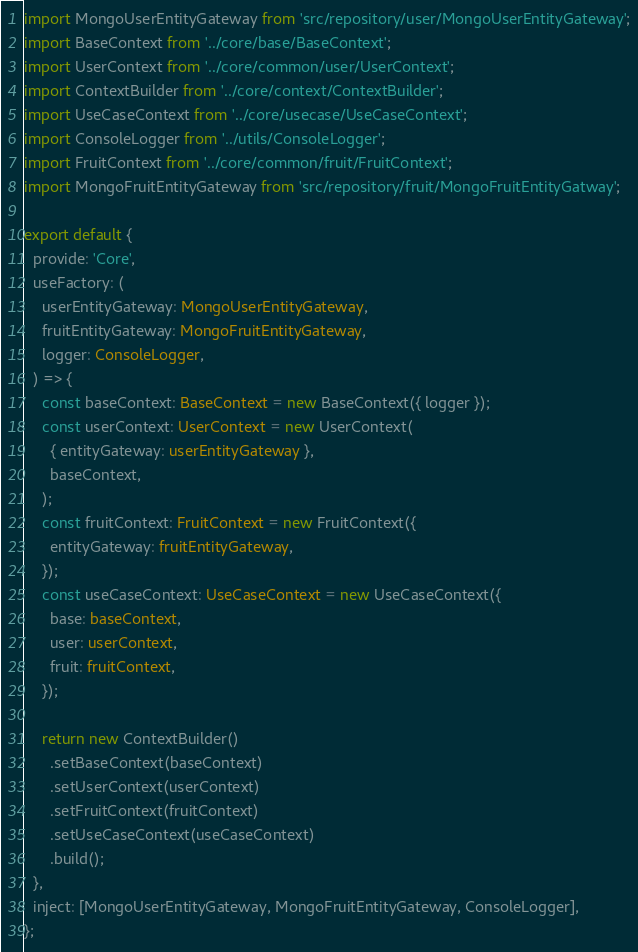Convert code to text. <code><loc_0><loc_0><loc_500><loc_500><_TypeScript_>import MongoUserEntityGateway from 'src/repository/user/MongoUserEntityGateway';
import BaseContext from '../core/base/BaseContext';
import UserContext from '../core/common/user/UserContext';
import ContextBuilder from '../core/context/ContextBuilder';
import UseCaseContext from '../core/usecase/UseCaseContext';
import ConsoleLogger from '../utils/ConsoleLogger';
import FruitContext from '../core/common/fruit/FruitContext';
import MongoFruitEntityGateway from 'src/repository/fruit/MongoFruitEntityGatway';

export default {
  provide: 'Core',
  useFactory: (
    userEntityGateway: MongoUserEntityGateway,
    fruitEntityGateway: MongoFruitEntityGateway,
    logger: ConsoleLogger,
  ) => {
    const baseContext: BaseContext = new BaseContext({ logger });
    const userContext: UserContext = new UserContext(
      { entityGateway: userEntityGateway },
      baseContext,
    );
    const fruitContext: FruitContext = new FruitContext({
      entityGateway: fruitEntityGateway,
    });
    const useCaseContext: UseCaseContext = new UseCaseContext({
      base: baseContext,
      user: userContext,
      fruit: fruitContext,
    });

    return new ContextBuilder()
      .setBaseContext(baseContext)
      .setUserContext(userContext)
      .setFruitContext(fruitContext)
      .setUseCaseContext(useCaseContext)
      .build();
  },
  inject: [MongoUserEntityGateway, MongoFruitEntityGateway, ConsoleLogger],
};
</code> 